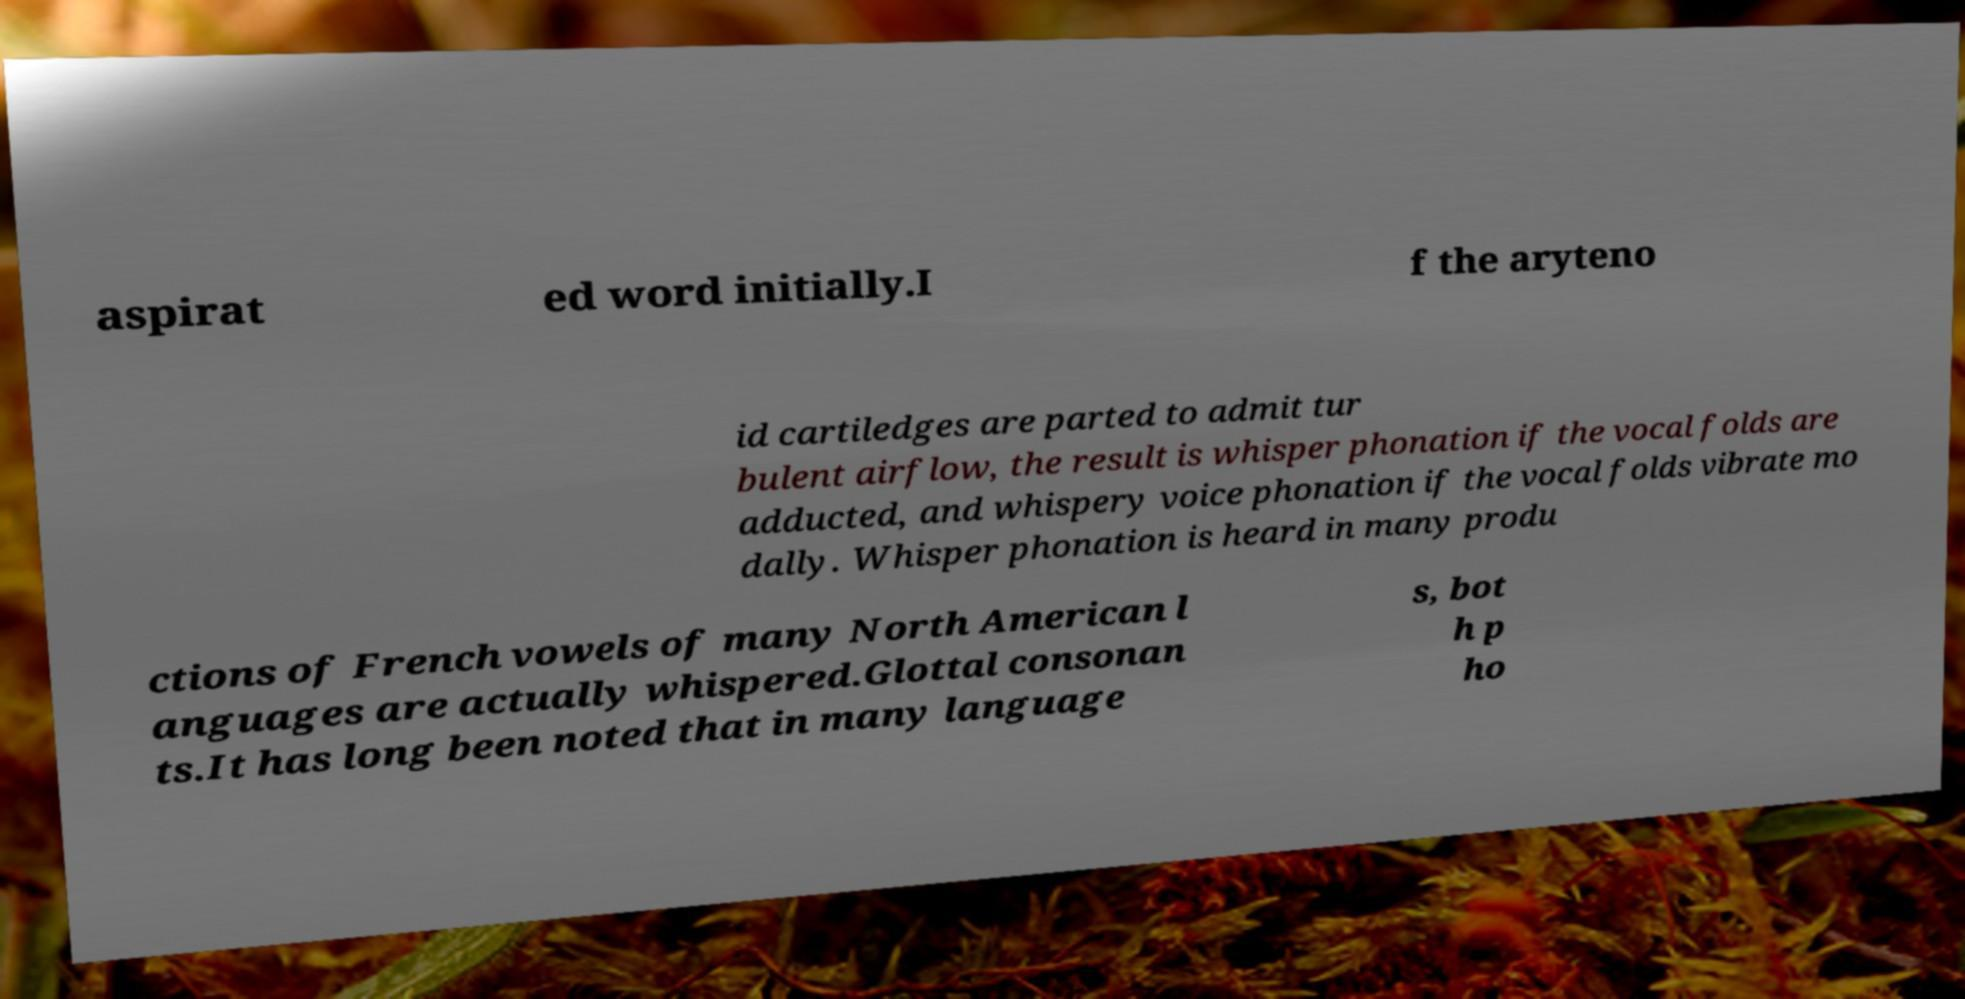Please identify and transcribe the text found in this image. aspirat ed word initially.I f the aryteno id cartiledges are parted to admit tur bulent airflow, the result is whisper phonation if the vocal folds are adducted, and whispery voice phonation if the vocal folds vibrate mo dally. Whisper phonation is heard in many produ ctions of French vowels of many North American l anguages are actually whispered.Glottal consonan ts.It has long been noted that in many language s, bot h p ho 